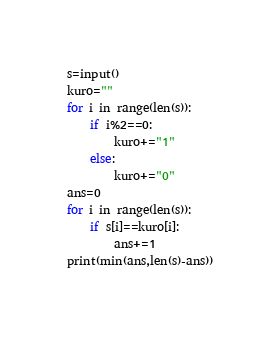<code> <loc_0><loc_0><loc_500><loc_500><_Python_>s=input()
kuro=""
for i in range(len(s)):
    if i%2==0:
        kuro+="1"
    else:
        kuro+="0"
ans=0
for i in range(len(s)):
    if s[i]==kuro[i]:
        ans+=1
print(min(ans,len(s)-ans))</code> 